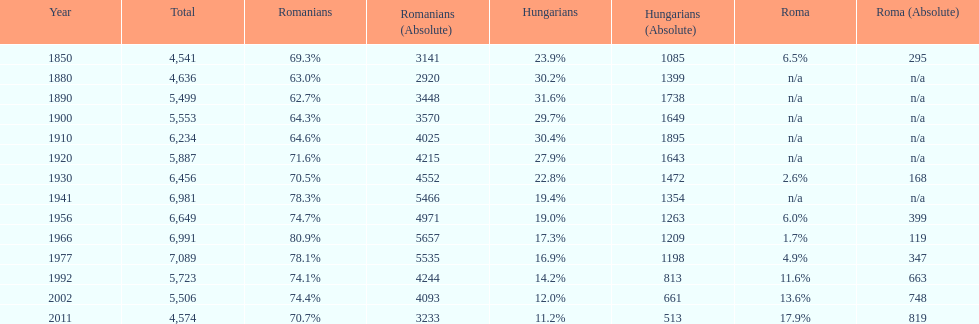What is the number of times the total population was 6,000 or more? 6. 